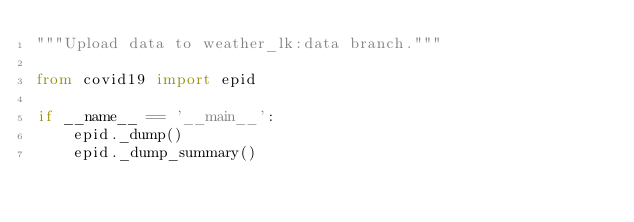Convert code to text. <code><loc_0><loc_0><loc_500><loc_500><_Python_>"""Upload data to weather_lk:data branch."""

from covid19 import epid

if __name__ == '__main__':
    epid._dump()
    epid._dump_summary()
</code> 